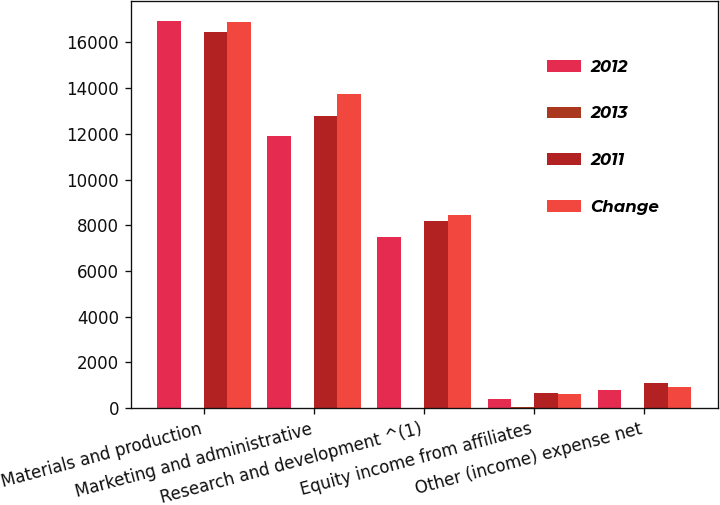Convert chart to OTSL. <chart><loc_0><loc_0><loc_500><loc_500><stacked_bar_chart><ecel><fcel>Materials and production<fcel>Marketing and administrative<fcel>Research and development ^(1)<fcel>Equity income from affiliates<fcel>Other (income) expense net<nl><fcel>2012<fcel>16954<fcel>11911<fcel>7503<fcel>404<fcel>815<nl><fcel>2013<fcel>3<fcel>7<fcel>8<fcel>37<fcel>27<nl><fcel>2011<fcel>16446<fcel>12776<fcel>8168<fcel>642<fcel>1116<nl><fcel>Change<fcel>16871<fcel>13733<fcel>8467<fcel>610<fcel>946<nl></chart> 